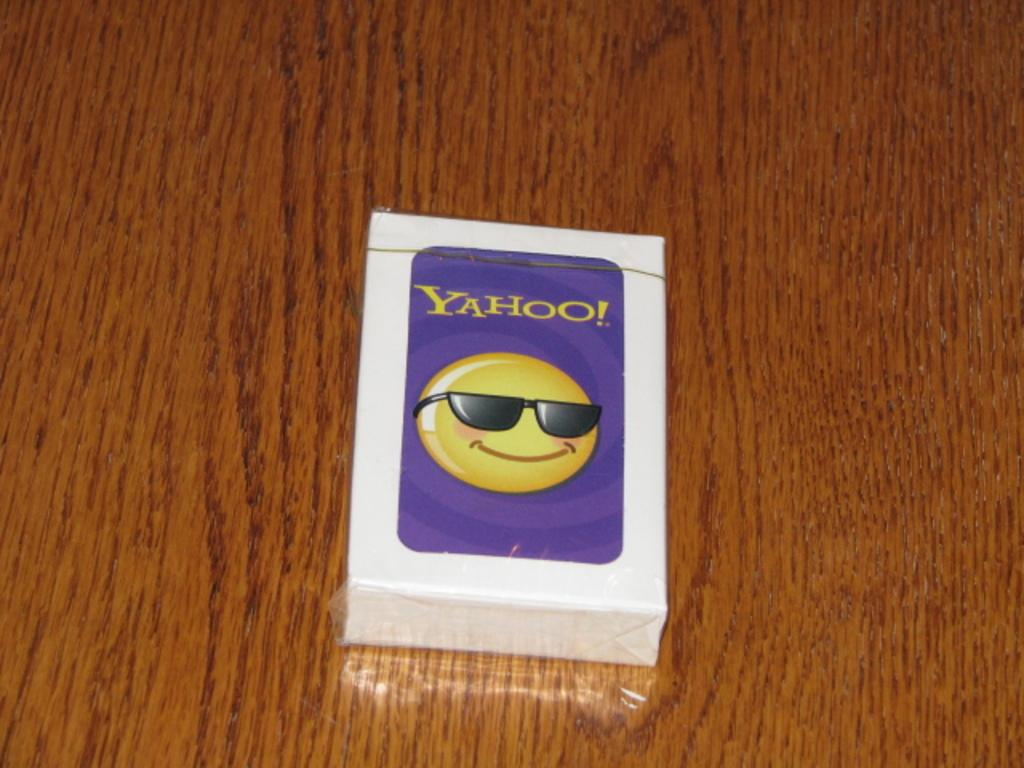What is the main object in the center of the image? There is a box in the center of the image. What is depicted on the box? There is an emoticon on the box. Are there any words or phrases on the box? Yes, there is text on the box. What is the box resting on in the image? The box is placed on a wooden object. How many toes can be seen on the rat in the image? There is no rat or toes present in the image; it features a box with an emoticon and text. 